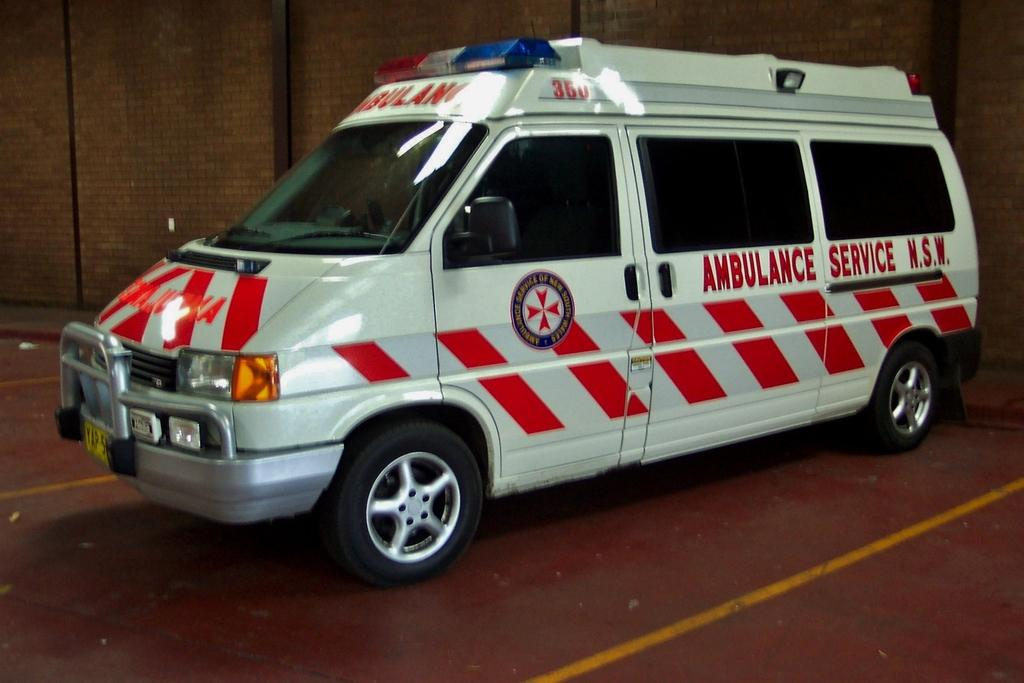<image>
Give a short and clear explanation of the subsequent image. an ambulance service that is on a van 